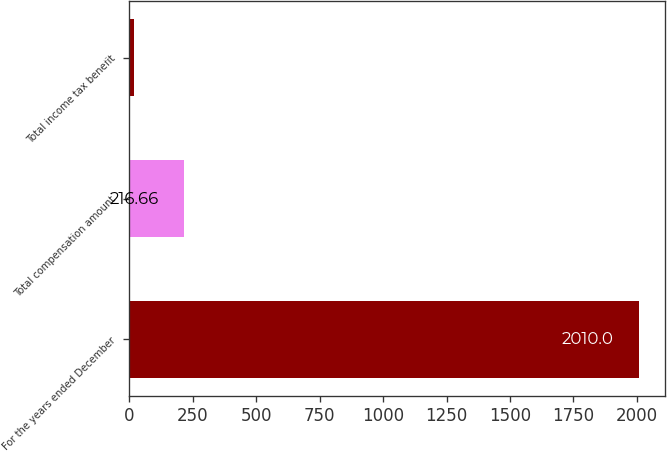<chart> <loc_0><loc_0><loc_500><loc_500><bar_chart><fcel>For the years ended December<fcel>Total compensation amount<fcel>Total income tax benefit<nl><fcel>2010<fcel>216.66<fcel>17.4<nl></chart> 